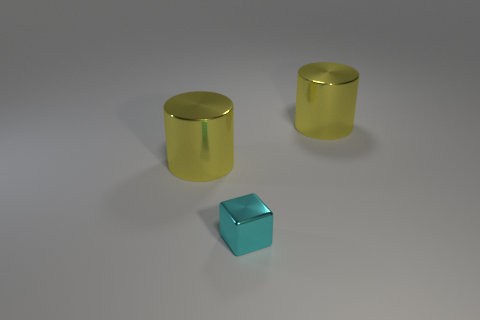What number of large cylinders are the same material as the small block? 2 